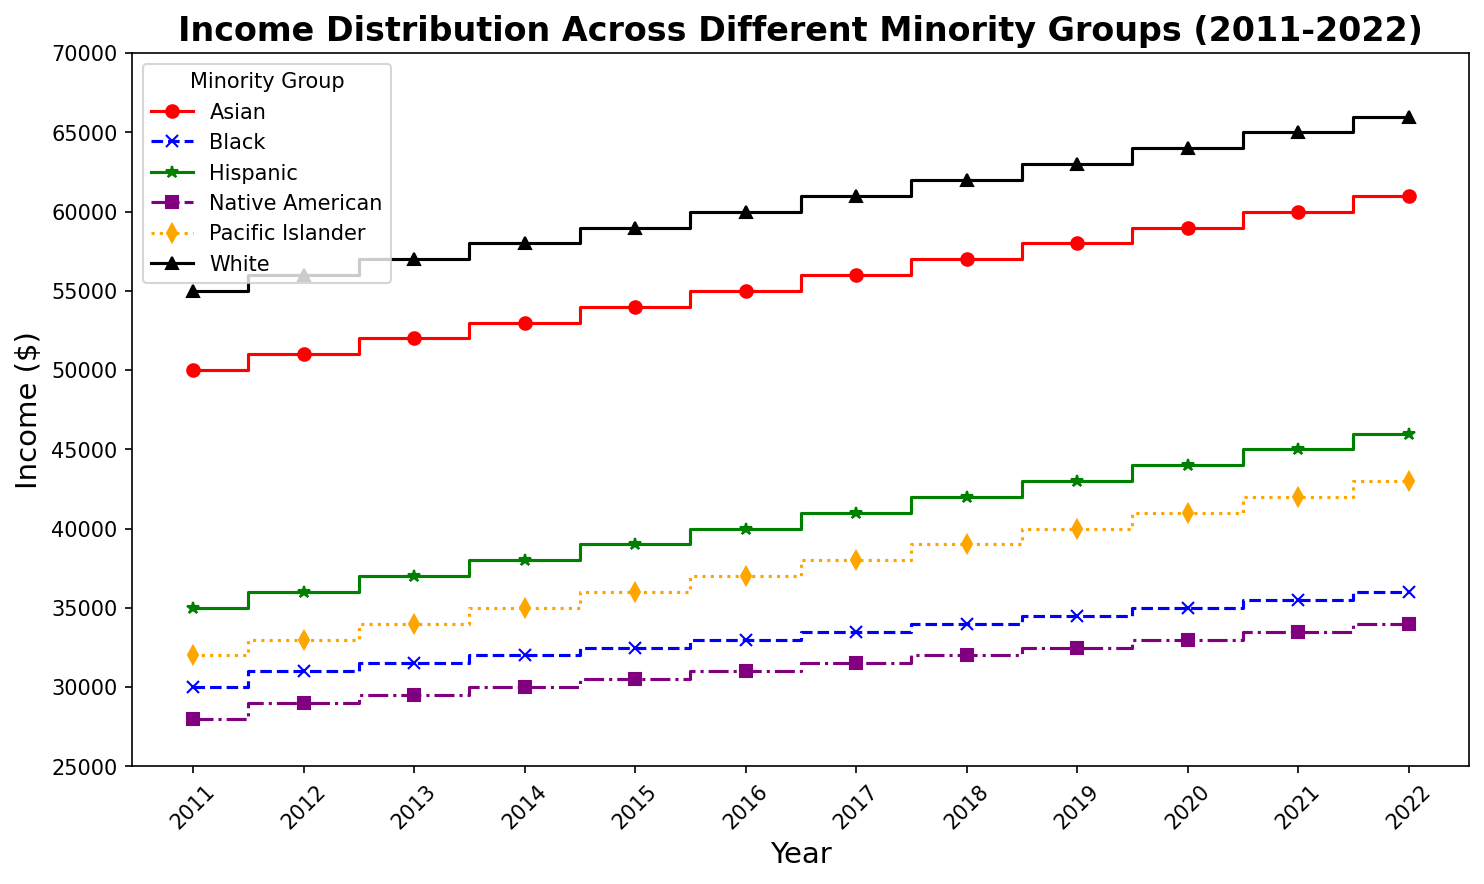What year did the Hispanic income first reach $40,000? Look at the data for Hispanic income over the years and identify the first year where the income is at or above $40,000. From the figure, it’s clear that the Hispanic income reaches $40,000 in 2016.
Answer: 2016 Which group had the highest increase in income from 2011 to 2022? Look at the income values for each group in 2011 and 2022, then calculate the increase (2022 income - 2011 income) for each group. The Asian group had the highest increase: $61,000 - $50,000 = $11,000.
Answer: Asian By how much did the income of the Native American group increase from 2014 to 2020? Look at the income for the Native American group in both 2014 and 2020, then subtract the 2014 value from the 2020 value. The income increased from $30,000 to $33,000, an increase of $3,000.
Answer: $3,000 Which group had the smallest income in 2015, and what was it? Look at the data for 2015 across all groups and identify the smallest income value. The Native American group had the smallest income of $30,000 in 2015.
Answer: Native American, $30,000 What is the average income for the Black group between 2018 and 2022? Calculate the average by summing the incomes for the Black group from 2018 to 2022 and then divide by the number of years (5). Sum: $34,000 + $34,500 + $35,000 + $35,500 + $36,000 = $174,000. Average is $174,000 / 5 = $34,800.
Answer: $34,800 Compare the income increase of the Pacific Islander group and the White group between 2011 and 2021. Which group had a higher rise and by how much? Calculate the income increase from 2011 to 2021 for both groups and compare. For Pacific Islanders: $42,000 - $32,000 = $10,000. For Whites: $65,000 - $55,000 = $10,000. Both groups had the same increase.
Answer: Same, $10,000 What is the difference in income between the White and Black groups in 2011, and how does it compare to the difference in 2022? Look at the income for both groups in 2011 and 2022 and calculate the differences. In 2011, the difference was $55,000 - $30,000 = $25,000. In 2022, the difference was $66,000 - $36,000 = $30,000. The difference increased by $5,000 from 2011 to 2022.
Answer: $25,000 (2011), $30,000 (2022), Increased by $5,000 What trend can be observed for the income of the Hispanic group over the decade? Observe the pattern/title and note the general trend. Starting from $35,000 in 2011 and increasing steadily to $46,000 in 2022, the trend shows consistent growth every year.
Answer: Steady increase 